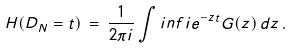Convert formula to latex. <formula><loc_0><loc_0><loc_500><loc_500>H ( D _ { N } = t ) \, = \, \frac { 1 } { 2 \pi i } \int i n f i e ^ { - z t } G ( z ) \, d z \, .</formula> 